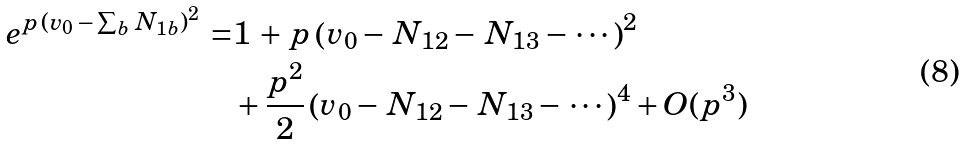Convert formula to latex. <formula><loc_0><loc_0><loc_500><loc_500>e ^ { p \, \left ( v _ { 0 } \, - \, \sum _ { b } \, N _ { 1 b } \right ) ^ { 2 } } \, = & 1 \, + \, p \left ( v _ { 0 } - \, N _ { 1 2 } - \, N _ { 1 3 } - \, \cdots \, \right ) ^ { 2 } \\ & + \frac { p ^ { 2 } } { 2 } \left ( v _ { 0 } - \, N _ { 1 2 } - \, N _ { 1 3 } - \, \cdots \, \right ) ^ { 4 } + O ( p ^ { 3 } )</formula> 